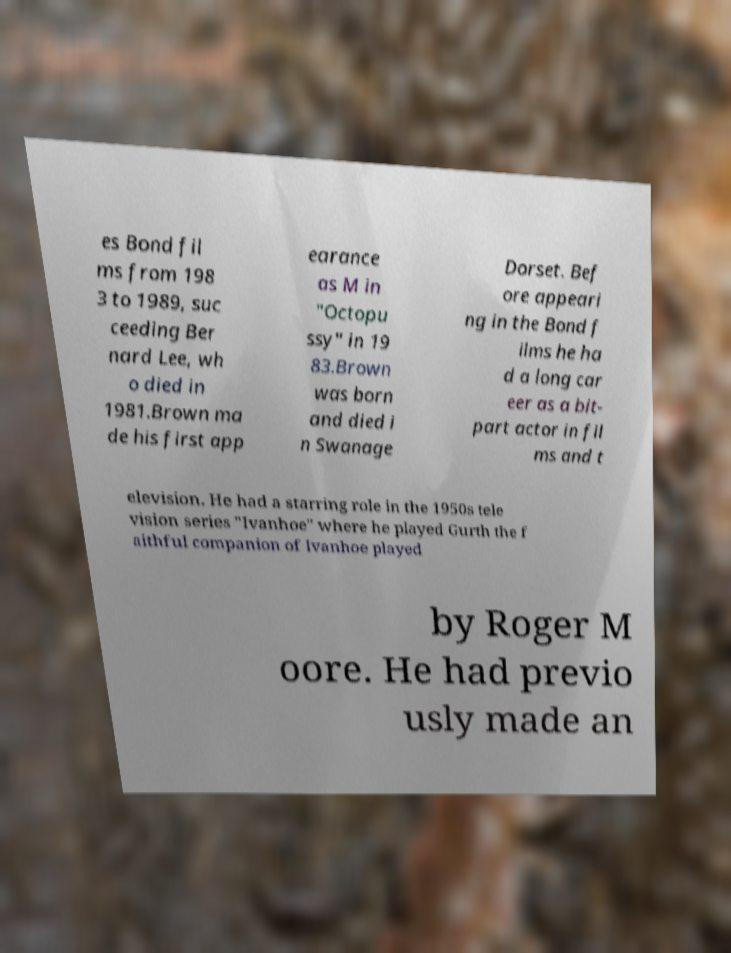Please read and relay the text visible in this image. What does it say? es Bond fil ms from 198 3 to 1989, suc ceeding Ber nard Lee, wh o died in 1981.Brown ma de his first app earance as M in "Octopu ssy" in 19 83.Brown was born and died i n Swanage Dorset. Bef ore appeari ng in the Bond f ilms he ha d a long car eer as a bit- part actor in fil ms and t elevision. He had a starring role in the 1950s tele vision series "Ivanhoe" where he played Gurth the f aithful companion of Ivanhoe played by Roger M oore. He had previo usly made an 